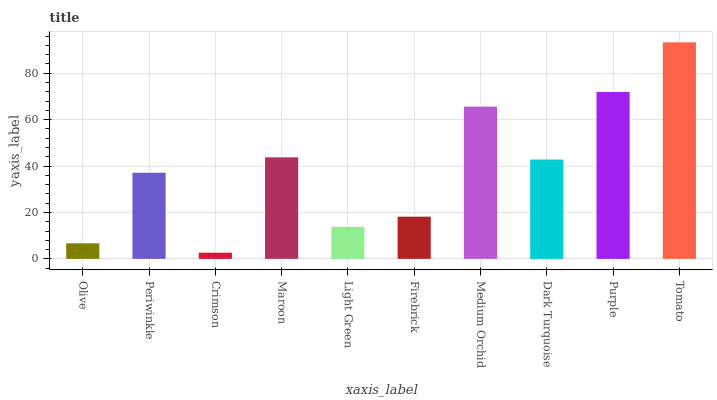Is Crimson the minimum?
Answer yes or no. Yes. Is Tomato the maximum?
Answer yes or no. Yes. Is Periwinkle the minimum?
Answer yes or no. No. Is Periwinkle the maximum?
Answer yes or no. No. Is Periwinkle greater than Olive?
Answer yes or no. Yes. Is Olive less than Periwinkle?
Answer yes or no. Yes. Is Olive greater than Periwinkle?
Answer yes or no. No. Is Periwinkle less than Olive?
Answer yes or no. No. Is Dark Turquoise the high median?
Answer yes or no. Yes. Is Periwinkle the low median?
Answer yes or no. Yes. Is Maroon the high median?
Answer yes or no. No. Is Medium Orchid the low median?
Answer yes or no. No. 